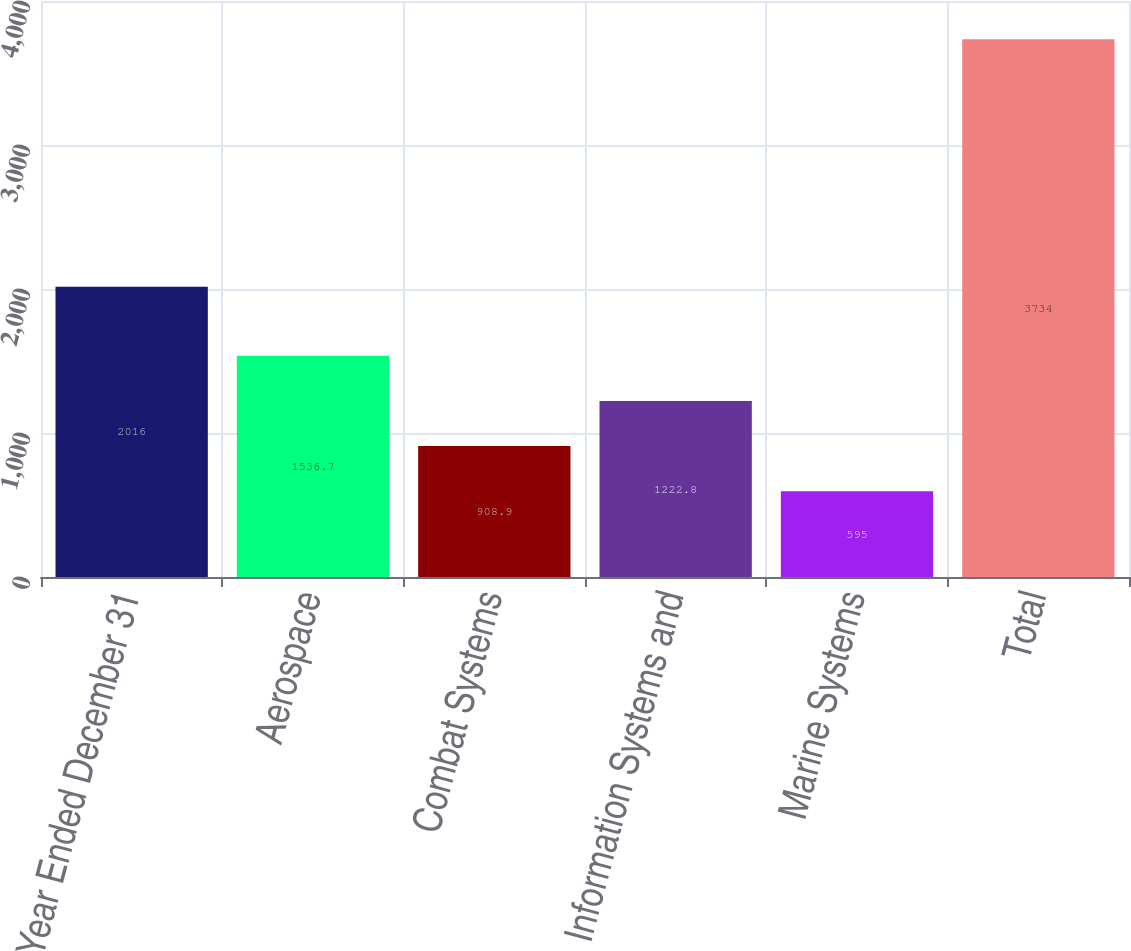<chart> <loc_0><loc_0><loc_500><loc_500><bar_chart><fcel>Year Ended December 31<fcel>Aerospace<fcel>Combat Systems<fcel>Information Systems and<fcel>Marine Systems<fcel>Total<nl><fcel>2016<fcel>1536.7<fcel>908.9<fcel>1222.8<fcel>595<fcel>3734<nl></chart> 